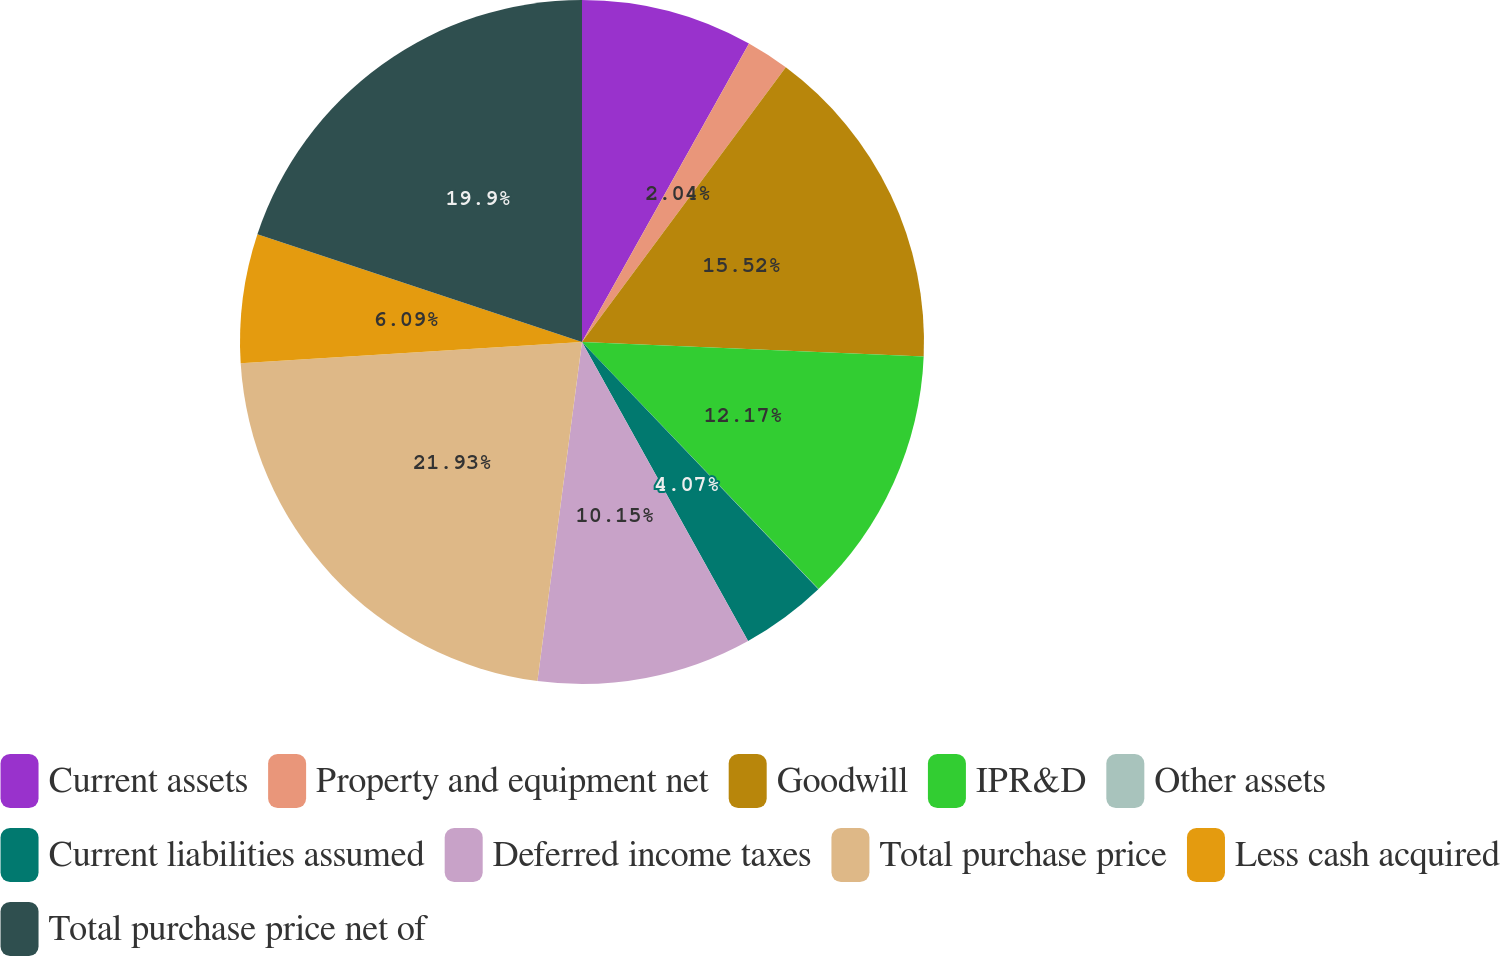<chart> <loc_0><loc_0><loc_500><loc_500><pie_chart><fcel>Current assets<fcel>Property and equipment net<fcel>Goodwill<fcel>IPR&D<fcel>Other assets<fcel>Current liabilities assumed<fcel>Deferred income taxes<fcel>Total purchase price<fcel>Less cash acquired<fcel>Total purchase price net of<nl><fcel>8.12%<fcel>2.04%<fcel>15.52%<fcel>12.17%<fcel>0.01%<fcel>4.07%<fcel>10.15%<fcel>21.93%<fcel>6.09%<fcel>19.9%<nl></chart> 